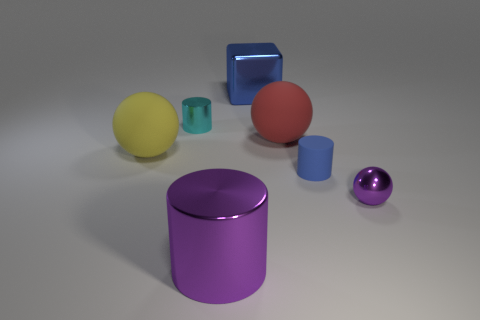The metallic ball is what color? purple 